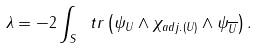Convert formula to latex. <formula><loc_0><loc_0><loc_500><loc_500>\lambda = - 2 \int _ { S } \ t r \left ( \psi _ { U } \wedge \chi _ { { a d j . } ( U ) } \wedge \psi _ { \overline { U } } \right ) .</formula> 